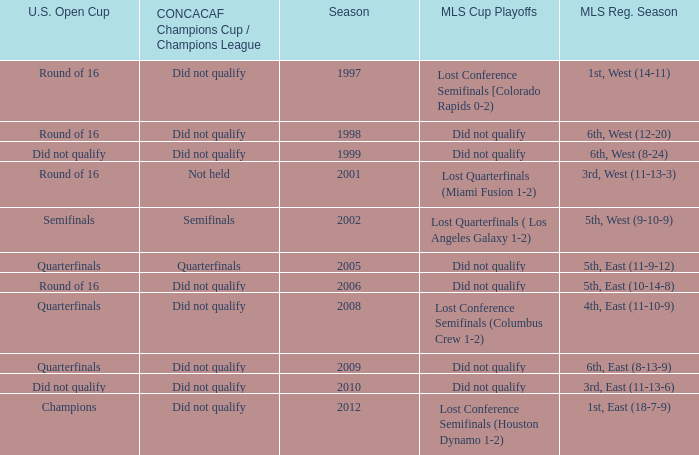When was the first season? 1997.0. 